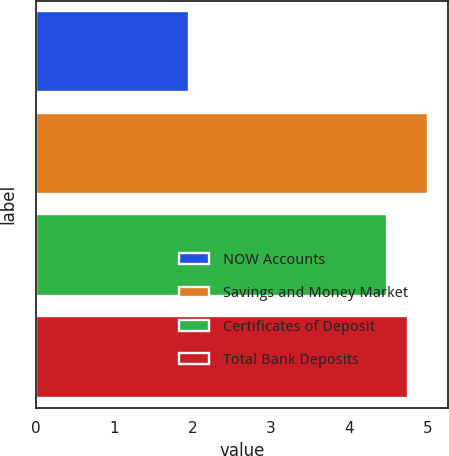<chart> <loc_0><loc_0><loc_500><loc_500><bar_chart><fcel>NOW Accounts<fcel>Savings and Money Market<fcel>Certificates of Deposit<fcel>Total Bank Deposits<nl><fcel>1.95<fcel>5.01<fcel>4.49<fcel>4.75<nl></chart> 